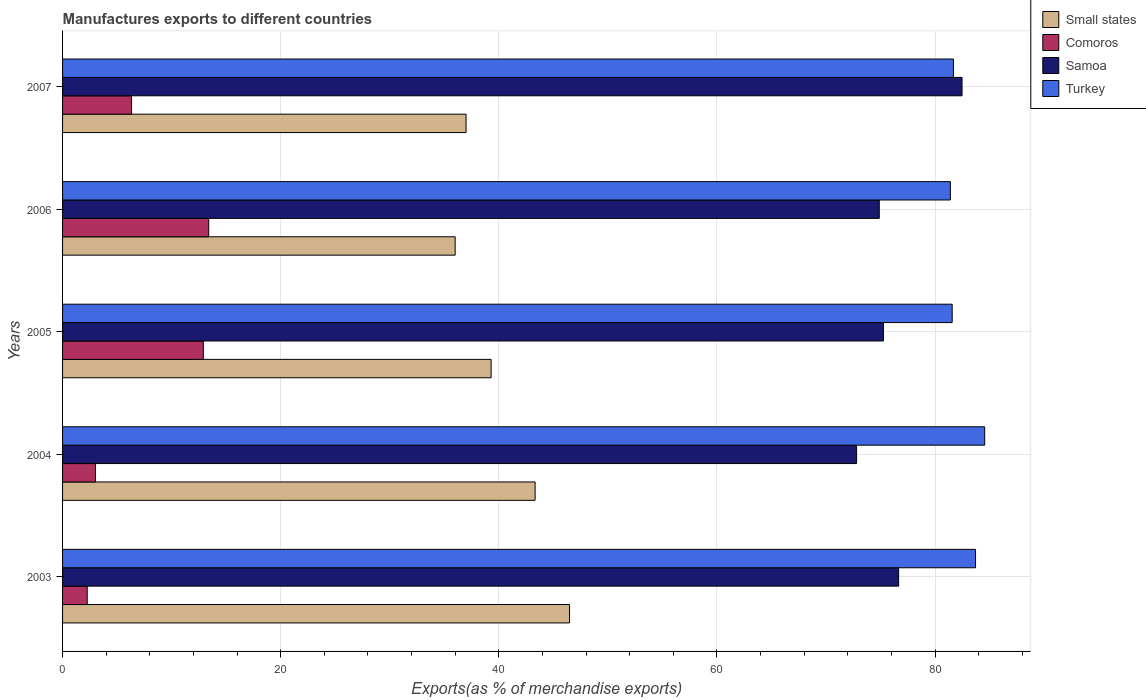What is the label of the 4th group of bars from the top?
Keep it short and to the point. 2004. In how many cases, is the number of bars for a given year not equal to the number of legend labels?
Offer a terse response. 0. What is the percentage of exports to different countries in Samoa in 2003?
Offer a terse response. 76.66. Across all years, what is the maximum percentage of exports to different countries in Small states?
Your answer should be compact. 46.48. Across all years, what is the minimum percentage of exports to different countries in Samoa?
Offer a terse response. 72.81. What is the total percentage of exports to different countries in Comoros in the graph?
Offer a very short reply. 37.9. What is the difference between the percentage of exports to different countries in Comoros in 2004 and that in 2005?
Your response must be concise. -9.89. What is the difference between the percentage of exports to different countries in Comoros in 2007 and the percentage of exports to different countries in Small states in 2003?
Provide a short and direct response. -40.16. What is the average percentage of exports to different countries in Samoa per year?
Offer a very short reply. 76.42. In the year 2003, what is the difference between the percentage of exports to different countries in Turkey and percentage of exports to different countries in Comoros?
Your response must be concise. 81.45. What is the ratio of the percentage of exports to different countries in Small states in 2003 to that in 2006?
Give a very brief answer. 1.29. Is the percentage of exports to different countries in Small states in 2005 less than that in 2007?
Your response must be concise. No. Is the difference between the percentage of exports to different countries in Turkey in 2003 and 2004 greater than the difference between the percentage of exports to different countries in Comoros in 2003 and 2004?
Provide a succinct answer. No. What is the difference between the highest and the second highest percentage of exports to different countries in Comoros?
Offer a terse response. 0.5. What is the difference between the highest and the lowest percentage of exports to different countries in Turkey?
Offer a very short reply. 3.15. Is the sum of the percentage of exports to different countries in Turkey in 2003 and 2007 greater than the maximum percentage of exports to different countries in Samoa across all years?
Provide a succinct answer. Yes. What does the 1st bar from the bottom in 2004 represents?
Your answer should be very brief. Small states. Are all the bars in the graph horizontal?
Make the answer very short. Yes. Are the values on the major ticks of X-axis written in scientific E-notation?
Offer a very short reply. No. Where does the legend appear in the graph?
Provide a short and direct response. Top right. How many legend labels are there?
Offer a very short reply. 4. How are the legend labels stacked?
Offer a very short reply. Vertical. What is the title of the graph?
Ensure brevity in your answer.  Manufactures exports to different countries. What is the label or title of the X-axis?
Offer a very short reply. Exports(as % of merchandise exports). What is the Exports(as % of merchandise exports) in Small states in 2003?
Give a very brief answer. 46.48. What is the Exports(as % of merchandise exports) in Comoros in 2003?
Your answer should be very brief. 2.26. What is the Exports(as % of merchandise exports) in Samoa in 2003?
Provide a short and direct response. 76.66. What is the Exports(as % of merchandise exports) in Turkey in 2003?
Provide a succinct answer. 83.71. What is the Exports(as % of merchandise exports) of Small states in 2004?
Provide a succinct answer. 43.33. What is the Exports(as % of merchandise exports) of Comoros in 2004?
Offer a terse response. 3.01. What is the Exports(as % of merchandise exports) of Samoa in 2004?
Your answer should be very brief. 72.81. What is the Exports(as % of merchandise exports) in Turkey in 2004?
Provide a short and direct response. 84.55. What is the Exports(as % of merchandise exports) in Small states in 2005?
Keep it short and to the point. 39.29. What is the Exports(as % of merchandise exports) in Comoros in 2005?
Provide a short and direct response. 12.9. What is the Exports(as % of merchandise exports) of Samoa in 2005?
Your response must be concise. 75.27. What is the Exports(as % of merchandise exports) in Turkey in 2005?
Provide a short and direct response. 81.57. What is the Exports(as % of merchandise exports) in Small states in 2006?
Make the answer very short. 36. What is the Exports(as % of merchandise exports) in Comoros in 2006?
Give a very brief answer. 13.4. What is the Exports(as % of merchandise exports) in Samoa in 2006?
Give a very brief answer. 74.89. What is the Exports(as % of merchandise exports) in Turkey in 2006?
Offer a terse response. 81.4. What is the Exports(as % of merchandise exports) in Small states in 2007?
Offer a terse response. 37. What is the Exports(as % of merchandise exports) of Comoros in 2007?
Keep it short and to the point. 6.33. What is the Exports(as % of merchandise exports) of Samoa in 2007?
Offer a very short reply. 82.47. What is the Exports(as % of merchandise exports) in Turkey in 2007?
Your answer should be very brief. 81.69. Across all years, what is the maximum Exports(as % of merchandise exports) in Small states?
Give a very brief answer. 46.48. Across all years, what is the maximum Exports(as % of merchandise exports) in Comoros?
Your answer should be very brief. 13.4. Across all years, what is the maximum Exports(as % of merchandise exports) in Samoa?
Give a very brief answer. 82.47. Across all years, what is the maximum Exports(as % of merchandise exports) in Turkey?
Your response must be concise. 84.55. Across all years, what is the minimum Exports(as % of merchandise exports) in Small states?
Your answer should be very brief. 36. Across all years, what is the minimum Exports(as % of merchandise exports) of Comoros?
Your answer should be very brief. 2.26. Across all years, what is the minimum Exports(as % of merchandise exports) in Samoa?
Offer a terse response. 72.81. Across all years, what is the minimum Exports(as % of merchandise exports) of Turkey?
Your answer should be very brief. 81.4. What is the total Exports(as % of merchandise exports) in Small states in the graph?
Ensure brevity in your answer.  202.1. What is the total Exports(as % of merchandise exports) in Comoros in the graph?
Keep it short and to the point. 37.9. What is the total Exports(as % of merchandise exports) in Samoa in the graph?
Offer a very short reply. 382.1. What is the total Exports(as % of merchandise exports) of Turkey in the graph?
Offer a terse response. 412.93. What is the difference between the Exports(as % of merchandise exports) of Small states in 2003 and that in 2004?
Ensure brevity in your answer.  3.16. What is the difference between the Exports(as % of merchandise exports) in Comoros in 2003 and that in 2004?
Keep it short and to the point. -0.76. What is the difference between the Exports(as % of merchandise exports) of Samoa in 2003 and that in 2004?
Your answer should be compact. 3.85. What is the difference between the Exports(as % of merchandise exports) in Turkey in 2003 and that in 2004?
Provide a succinct answer. -0.84. What is the difference between the Exports(as % of merchandise exports) in Small states in 2003 and that in 2005?
Ensure brevity in your answer.  7.19. What is the difference between the Exports(as % of merchandise exports) of Comoros in 2003 and that in 2005?
Your answer should be very brief. -10.64. What is the difference between the Exports(as % of merchandise exports) of Samoa in 2003 and that in 2005?
Ensure brevity in your answer.  1.4. What is the difference between the Exports(as % of merchandise exports) in Turkey in 2003 and that in 2005?
Provide a short and direct response. 2.14. What is the difference between the Exports(as % of merchandise exports) of Small states in 2003 and that in 2006?
Give a very brief answer. 10.49. What is the difference between the Exports(as % of merchandise exports) in Comoros in 2003 and that in 2006?
Give a very brief answer. -11.14. What is the difference between the Exports(as % of merchandise exports) of Samoa in 2003 and that in 2006?
Give a very brief answer. 1.78. What is the difference between the Exports(as % of merchandise exports) in Turkey in 2003 and that in 2006?
Keep it short and to the point. 2.31. What is the difference between the Exports(as % of merchandise exports) of Small states in 2003 and that in 2007?
Ensure brevity in your answer.  9.49. What is the difference between the Exports(as % of merchandise exports) of Comoros in 2003 and that in 2007?
Give a very brief answer. -4.07. What is the difference between the Exports(as % of merchandise exports) of Samoa in 2003 and that in 2007?
Offer a terse response. -5.81. What is the difference between the Exports(as % of merchandise exports) in Turkey in 2003 and that in 2007?
Your response must be concise. 2.03. What is the difference between the Exports(as % of merchandise exports) in Small states in 2004 and that in 2005?
Provide a succinct answer. 4.04. What is the difference between the Exports(as % of merchandise exports) in Comoros in 2004 and that in 2005?
Your response must be concise. -9.89. What is the difference between the Exports(as % of merchandise exports) of Samoa in 2004 and that in 2005?
Your answer should be very brief. -2.46. What is the difference between the Exports(as % of merchandise exports) in Turkey in 2004 and that in 2005?
Your answer should be compact. 2.98. What is the difference between the Exports(as % of merchandise exports) in Small states in 2004 and that in 2006?
Your response must be concise. 7.33. What is the difference between the Exports(as % of merchandise exports) of Comoros in 2004 and that in 2006?
Your answer should be very brief. -10.39. What is the difference between the Exports(as % of merchandise exports) in Samoa in 2004 and that in 2006?
Offer a terse response. -2.08. What is the difference between the Exports(as % of merchandise exports) of Turkey in 2004 and that in 2006?
Your answer should be compact. 3.15. What is the difference between the Exports(as % of merchandise exports) in Small states in 2004 and that in 2007?
Ensure brevity in your answer.  6.33. What is the difference between the Exports(as % of merchandise exports) in Comoros in 2004 and that in 2007?
Your answer should be compact. -3.31. What is the difference between the Exports(as % of merchandise exports) of Samoa in 2004 and that in 2007?
Offer a very short reply. -9.67. What is the difference between the Exports(as % of merchandise exports) of Turkey in 2004 and that in 2007?
Provide a succinct answer. 2.86. What is the difference between the Exports(as % of merchandise exports) of Small states in 2005 and that in 2006?
Ensure brevity in your answer.  3.3. What is the difference between the Exports(as % of merchandise exports) in Comoros in 2005 and that in 2006?
Give a very brief answer. -0.5. What is the difference between the Exports(as % of merchandise exports) in Samoa in 2005 and that in 2006?
Offer a terse response. 0.38. What is the difference between the Exports(as % of merchandise exports) in Turkey in 2005 and that in 2006?
Your answer should be compact. 0.17. What is the difference between the Exports(as % of merchandise exports) of Small states in 2005 and that in 2007?
Your response must be concise. 2.3. What is the difference between the Exports(as % of merchandise exports) of Comoros in 2005 and that in 2007?
Offer a very short reply. 6.58. What is the difference between the Exports(as % of merchandise exports) of Samoa in 2005 and that in 2007?
Your answer should be very brief. -7.21. What is the difference between the Exports(as % of merchandise exports) in Turkey in 2005 and that in 2007?
Keep it short and to the point. -0.11. What is the difference between the Exports(as % of merchandise exports) in Small states in 2006 and that in 2007?
Ensure brevity in your answer.  -1. What is the difference between the Exports(as % of merchandise exports) in Comoros in 2006 and that in 2007?
Ensure brevity in your answer.  7.07. What is the difference between the Exports(as % of merchandise exports) of Samoa in 2006 and that in 2007?
Ensure brevity in your answer.  -7.59. What is the difference between the Exports(as % of merchandise exports) of Turkey in 2006 and that in 2007?
Provide a short and direct response. -0.28. What is the difference between the Exports(as % of merchandise exports) of Small states in 2003 and the Exports(as % of merchandise exports) of Comoros in 2004?
Your response must be concise. 43.47. What is the difference between the Exports(as % of merchandise exports) of Small states in 2003 and the Exports(as % of merchandise exports) of Samoa in 2004?
Offer a terse response. -26.32. What is the difference between the Exports(as % of merchandise exports) of Small states in 2003 and the Exports(as % of merchandise exports) of Turkey in 2004?
Give a very brief answer. -38.07. What is the difference between the Exports(as % of merchandise exports) of Comoros in 2003 and the Exports(as % of merchandise exports) of Samoa in 2004?
Offer a terse response. -70.55. What is the difference between the Exports(as % of merchandise exports) in Comoros in 2003 and the Exports(as % of merchandise exports) in Turkey in 2004?
Your answer should be very brief. -82.29. What is the difference between the Exports(as % of merchandise exports) of Samoa in 2003 and the Exports(as % of merchandise exports) of Turkey in 2004?
Your answer should be compact. -7.89. What is the difference between the Exports(as % of merchandise exports) of Small states in 2003 and the Exports(as % of merchandise exports) of Comoros in 2005?
Your response must be concise. 33.58. What is the difference between the Exports(as % of merchandise exports) in Small states in 2003 and the Exports(as % of merchandise exports) in Samoa in 2005?
Your answer should be compact. -28.78. What is the difference between the Exports(as % of merchandise exports) in Small states in 2003 and the Exports(as % of merchandise exports) in Turkey in 2005?
Your response must be concise. -35.09. What is the difference between the Exports(as % of merchandise exports) of Comoros in 2003 and the Exports(as % of merchandise exports) of Samoa in 2005?
Your response must be concise. -73.01. What is the difference between the Exports(as % of merchandise exports) of Comoros in 2003 and the Exports(as % of merchandise exports) of Turkey in 2005?
Offer a terse response. -79.31. What is the difference between the Exports(as % of merchandise exports) of Samoa in 2003 and the Exports(as % of merchandise exports) of Turkey in 2005?
Your response must be concise. -4.91. What is the difference between the Exports(as % of merchandise exports) of Small states in 2003 and the Exports(as % of merchandise exports) of Comoros in 2006?
Provide a succinct answer. 33.08. What is the difference between the Exports(as % of merchandise exports) of Small states in 2003 and the Exports(as % of merchandise exports) of Samoa in 2006?
Your answer should be very brief. -28.4. What is the difference between the Exports(as % of merchandise exports) in Small states in 2003 and the Exports(as % of merchandise exports) in Turkey in 2006?
Offer a terse response. -34.92. What is the difference between the Exports(as % of merchandise exports) of Comoros in 2003 and the Exports(as % of merchandise exports) of Samoa in 2006?
Provide a succinct answer. -72.63. What is the difference between the Exports(as % of merchandise exports) of Comoros in 2003 and the Exports(as % of merchandise exports) of Turkey in 2006?
Your answer should be very brief. -79.15. What is the difference between the Exports(as % of merchandise exports) of Samoa in 2003 and the Exports(as % of merchandise exports) of Turkey in 2006?
Your answer should be compact. -4.74. What is the difference between the Exports(as % of merchandise exports) of Small states in 2003 and the Exports(as % of merchandise exports) of Comoros in 2007?
Your response must be concise. 40.16. What is the difference between the Exports(as % of merchandise exports) in Small states in 2003 and the Exports(as % of merchandise exports) in Samoa in 2007?
Offer a terse response. -35.99. What is the difference between the Exports(as % of merchandise exports) of Small states in 2003 and the Exports(as % of merchandise exports) of Turkey in 2007?
Offer a terse response. -35.2. What is the difference between the Exports(as % of merchandise exports) in Comoros in 2003 and the Exports(as % of merchandise exports) in Samoa in 2007?
Give a very brief answer. -80.22. What is the difference between the Exports(as % of merchandise exports) in Comoros in 2003 and the Exports(as % of merchandise exports) in Turkey in 2007?
Ensure brevity in your answer.  -79.43. What is the difference between the Exports(as % of merchandise exports) in Samoa in 2003 and the Exports(as % of merchandise exports) in Turkey in 2007?
Make the answer very short. -5.02. What is the difference between the Exports(as % of merchandise exports) in Small states in 2004 and the Exports(as % of merchandise exports) in Comoros in 2005?
Offer a very short reply. 30.43. What is the difference between the Exports(as % of merchandise exports) in Small states in 2004 and the Exports(as % of merchandise exports) in Samoa in 2005?
Provide a succinct answer. -31.94. What is the difference between the Exports(as % of merchandise exports) of Small states in 2004 and the Exports(as % of merchandise exports) of Turkey in 2005?
Provide a succinct answer. -38.24. What is the difference between the Exports(as % of merchandise exports) of Comoros in 2004 and the Exports(as % of merchandise exports) of Samoa in 2005?
Give a very brief answer. -72.25. What is the difference between the Exports(as % of merchandise exports) of Comoros in 2004 and the Exports(as % of merchandise exports) of Turkey in 2005?
Your answer should be very brief. -78.56. What is the difference between the Exports(as % of merchandise exports) in Samoa in 2004 and the Exports(as % of merchandise exports) in Turkey in 2005?
Give a very brief answer. -8.76. What is the difference between the Exports(as % of merchandise exports) in Small states in 2004 and the Exports(as % of merchandise exports) in Comoros in 2006?
Offer a terse response. 29.93. What is the difference between the Exports(as % of merchandise exports) in Small states in 2004 and the Exports(as % of merchandise exports) in Samoa in 2006?
Provide a succinct answer. -31.56. What is the difference between the Exports(as % of merchandise exports) of Small states in 2004 and the Exports(as % of merchandise exports) of Turkey in 2006?
Make the answer very short. -38.08. What is the difference between the Exports(as % of merchandise exports) of Comoros in 2004 and the Exports(as % of merchandise exports) of Samoa in 2006?
Make the answer very short. -71.87. What is the difference between the Exports(as % of merchandise exports) in Comoros in 2004 and the Exports(as % of merchandise exports) in Turkey in 2006?
Your answer should be very brief. -78.39. What is the difference between the Exports(as % of merchandise exports) in Samoa in 2004 and the Exports(as % of merchandise exports) in Turkey in 2006?
Provide a succinct answer. -8.6. What is the difference between the Exports(as % of merchandise exports) in Small states in 2004 and the Exports(as % of merchandise exports) in Comoros in 2007?
Make the answer very short. 37. What is the difference between the Exports(as % of merchandise exports) in Small states in 2004 and the Exports(as % of merchandise exports) in Samoa in 2007?
Offer a very short reply. -39.15. What is the difference between the Exports(as % of merchandise exports) in Small states in 2004 and the Exports(as % of merchandise exports) in Turkey in 2007?
Provide a short and direct response. -38.36. What is the difference between the Exports(as % of merchandise exports) in Comoros in 2004 and the Exports(as % of merchandise exports) in Samoa in 2007?
Offer a terse response. -79.46. What is the difference between the Exports(as % of merchandise exports) in Comoros in 2004 and the Exports(as % of merchandise exports) in Turkey in 2007?
Offer a very short reply. -78.67. What is the difference between the Exports(as % of merchandise exports) in Samoa in 2004 and the Exports(as % of merchandise exports) in Turkey in 2007?
Your answer should be very brief. -8.88. What is the difference between the Exports(as % of merchandise exports) of Small states in 2005 and the Exports(as % of merchandise exports) of Comoros in 2006?
Your response must be concise. 25.89. What is the difference between the Exports(as % of merchandise exports) in Small states in 2005 and the Exports(as % of merchandise exports) in Samoa in 2006?
Provide a succinct answer. -35.59. What is the difference between the Exports(as % of merchandise exports) of Small states in 2005 and the Exports(as % of merchandise exports) of Turkey in 2006?
Give a very brief answer. -42.11. What is the difference between the Exports(as % of merchandise exports) in Comoros in 2005 and the Exports(as % of merchandise exports) in Samoa in 2006?
Offer a very short reply. -61.98. What is the difference between the Exports(as % of merchandise exports) in Comoros in 2005 and the Exports(as % of merchandise exports) in Turkey in 2006?
Your answer should be very brief. -68.5. What is the difference between the Exports(as % of merchandise exports) in Samoa in 2005 and the Exports(as % of merchandise exports) in Turkey in 2006?
Your response must be concise. -6.14. What is the difference between the Exports(as % of merchandise exports) of Small states in 2005 and the Exports(as % of merchandise exports) of Comoros in 2007?
Make the answer very short. 32.97. What is the difference between the Exports(as % of merchandise exports) of Small states in 2005 and the Exports(as % of merchandise exports) of Samoa in 2007?
Make the answer very short. -43.18. What is the difference between the Exports(as % of merchandise exports) of Small states in 2005 and the Exports(as % of merchandise exports) of Turkey in 2007?
Give a very brief answer. -42.39. What is the difference between the Exports(as % of merchandise exports) of Comoros in 2005 and the Exports(as % of merchandise exports) of Samoa in 2007?
Your response must be concise. -69.57. What is the difference between the Exports(as % of merchandise exports) in Comoros in 2005 and the Exports(as % of merchandise exports) in Turkey in 2007?
Your answer should be compact. -68.78. What is the difference between the Exports(as % of merchandise exports) in Samoa in 2005 and the Exports(as % of merchandise exports) in Turkey in 2007?
Give a very brief answer. -6.42. What is the difference between the Exports(as % of merchandise exports) of Small states in 2006 and the Exports(as % of merchandise exports) of Comoros in 2007?
Provide a succinct answer. 29.67. What is the difference between the Exports(as % of merchandise exports) in Small states in 2006 and the Exports(as % of merchandise exports) in Samoa in 2007?
Offer a terse response. -46.48. What is the difference between the Exports(as % of merchandise exports) of Small states in 2006 and the Exports(as % of merchandise exports) of Turkey in 2007?
Give a very brief answer. -45.69. What is the difference between the Exports(as % of merchandise exports) of Comoros in 2006 and the Exports(as % of merchandise exports) of Samoa in 2007?
Your response must be concise. -69.08. What is the difference between the Exports(as % of merchandise exports) of Comoros in 2006 and the Exports(as % of merchandise exports) of Turkey in 2007?
Your answer should be very brief. -68.29. What is the difference between the Exports(as % of merchandise exports) of Samoa in 2006 and the Exports(as % of merchandise exports) of Turkey in 2007?
Your answer should be compact. -6.8. What is the average Exports(as % of merchandise exports) of Small states per year?
Ensure brevity in your answer.  40.42. What is the average Exports(as % of merchandise exports) of Comoros per year?
Provide a succinct answer. 7.58. What is the average Exports(as % of merchandise exports) in Samoa per year?
Provide a succinct answer. 76.42. What is the average Exports(as % of merchandise exports) in Turkey per year?
Provide a short and direct response. 82.59. In the year 2003, what is the difference between the Exports(as % of merchandise exports) in Small states and Exports(as % of merchandise exports) in Comoros?
Offer a very short reply. 44.23. In the year 2003, what is the difference between the Exports(as % of merchandise exports) in Small states and Exports(as % of merchandise exports) in Samoa?
Ensure brevity in your answer.  -30.18. In the year 2003, what is the difference between the Exports(as % of merchandise exports) in Small states and Exports(as % of merchandise exports) in Turkey?
Your answer should be compact. -37.23. In the year 2003, what is the difference between the Exports(as % of merchandise exports) in Comoros and Exports(as % of merchandise exports) in Samoa?
Your answer should be very brief. -74.4. In the year 2003, what is the difference between the Exports(as % of merchandise exports) in Comoros and Exports(as % of merchandise exports) in Turkey?
Offer a very short reply. -81.45. In the year 2003, what is the difference between the Exports(as % of merchandise exports) of Samoa and Exports(as % of merchandise exports) of Turkey?
Your answer should be very brief. -7.05. In the year 2004, what is the difference between the Exports(as % of merchandise exports) in Small states and Exports(as % of merchandise exports) in Comoros?
Give a very brief answer. 40.32. In the year 2004, what is the difference between the Exports(as % of merchandise exports) of Small states and Exports(as % of merchandise exports) of Samoa?
Your answer should be very brief. -29.48. In the year 2004, what is the difference between the Exports(as % of merchandise exports) in Small states and Exports(as % of merchandise exports) in Turkey?
Offer a terse response. -41.22. In the year 2004, what is the difference between the Exports(as % of merchandise exports) of Comoros and Exports(as % of merchandise exports) of Samoa?
Your response must be concise. -69.79. In the year 2004, what is the difference between the Exports(as % of merchandise exports) of Comoros and Exports(as % of merchandise exports) of Turkey?
Offer a very short reply. -81.54. In the year 2004, what is the difference between the Exports(as % of merchandise exports) in Samoa and Exports(as % of merchandise exports) in Turkey?
Your answer should be compact. -11.74. In the year 2005, what is the difference between the Exports(as % of merchandise exports) in Small states and Exports(as % of merchandise exports) in Comoros?
Provide a succinct answer. 26.39. In the year 2005, what is the difference between the Exports(as % of merchandise exports) of Small states and Exports(as % of merchandise exports) of Samoa?
Your answer should be compact. -35.97. In the year 2005, what is the difference between the Exports(as % of merchandise exports) of Small states and Exports(as % of merchandise exports) of Turkey?
Ensure brevity in your answer.  -42.28. In the year 2005, what is the difference between the Exports(as % of merchandise exports) of Comoros and Exports(as % of merchandise exports) of Samoa?
Ensure brevity in your answer.  -62.36. In the year 2005, what is the difference between the Exports(as % of merchandise exports) in Comoros and Exports(as % of merchandise exports) in Turkey?
Ensure brevity in your answer.  -68.67. In the year 2005, what is the difference between the Exports(as % of merchandise exports) of Samoa and Exports(as % of merchandise exports) of Turkey?
Offer a very short reply. -6.31. In the year 2006, what is the difference between the Exports(as % of merchandise exports) of Small states and Exports(as % of merchandise exports) of Comoros?
Provide a short and direct response. 22.6. In the year 2006, what is the difference between the Exports(as % of merchandise exports) of Small states and Exports(as % of merchandise exports) of Samoa?
Keep it short and to the point. -38.89. In the year 2006, what is the difference between the Exports(as % of merchandise exports) in Small states and Exports(as % of merchandise exports) in Turkey?
Ensure brevity in your answer.  -45.41. In the year 2006, what is the difference between the Exports(as % of merchandise exports) in Comoros and Exports(as % of merchandise exports) in Samoa?
Your response must be concise. -61.49. In the year 2006, what is the difference between the Exports(as % of merchandise exports) in Comoros and Exports(as % of merchandise exports) in Turkey?
Make the answer very short. -68. In the year 2006, what is the difference between the Exports(as % of merchandise exports) of Samoa and Exports(as % of merchandise exports) of Turkey?
Keep it short and to the point. -6.52. In the year 2007, what is the difference between the Exports(as % of merchandise exports) in Small states and Exports(as % of merchandise exports) in Comoros?
Your answer should be very brief. 30.67. In the year 2007, what is the difference between the Exports(as % of merchandise exports) in Small states and Exports(as % of merchandise exports) in Samoa?
Ensure brevity in your answer.  -45.48. In the year 2007, what is the difference between the Exports(as % of merchandise exports) of Small states and Exports(as % of merchandise exports) of Turkey?
Make the answer very short. -44.69. In the year 2007, what is the difference between the Exports(as % of merchandise exports) in Comoros and Exports(as % of merchandise exports) in Samoa?
Your answer should be compact. -76.15. In the year 2007, what is the difference between the Exports(as % of merchandise exports) in Comoros and Exports(as % of merchandise exports) in Turkey?
Offer a very short reply. -75.36. In the year 2007, what is the difference between the Exports(as % of merchandise exports) in Samoa and Exports(as % of merchandise exports) in Turkey?
Your answer should be compact. 0.79. What is the ratio of the Exports(as % of merchandise exports) of Small states in 2003 to that in 2004?
Offer a very short reply. 1.07. What is the ratio of the Exports(as % of merchandise exports) of Comoros in 2003 to that in 2004?
Make the answer very short. 0.75. What is the ratio of the Exports(as % of merchandise exports) of Samoa in 2003 to that in 2004?
Your answer should be compact. 1.05. What is the ratio of the Exports(as % of merchandise exports) in Small states in 2003 to that in 2005?
Provide a short and direct response. 1.18. What is the ratio of the Exports(as % of merchandise exports) in Comoros in 2003 to that in 2005?
Offer a very short reply. 0.17. What is the ratio of the Exports(as % of merchandise exports) in Samoa in 2003 to that in 2005?
Your answer should be very brief. 1.02. What is the ratio of the Exports(as % of merchandise exports) of Turkey in 2003 to that in 2005?
Give a very brief answer. 1.03. What is the ratio of the Exports(as % of merchandise exports) in Small states in 2003 to that in 2006?
Offer a very short reply. 1.29. What is the ratio of the Exports(as % of merchandise exports) of Comoros in 2003 to that in 2006?
Provide a short and direct response. 0.17. What is the ratio of the Exports(as % of merchandise exports) in Samoa in 2003 to that in 2006?
Your answer should be very brief. 1.02. What is the ratio of the Exports(as % of merchandise exports) of Turkey in 2003 to that in 2006?
Make the answer very short. 1.03. What is the ratio of the Exports(as % of merchandise exports) in Small states in 2003 to that in 2007?
Offer a very short reply. 1.26. What is the ratio of the Exports(as % of merchandise exports) of Comoros in 2003 to that in 2007?
Give a very brief answer. 0.36. What is the ratio of the Exports(as % of merchandise exports) in Samoa in 2003 to that in 2007?
Provide a short and direct response. 0.93. What is the ratio of the Exports(as % of merchandise exports) in Turkey in 2003 to that in 2007?
Provide a succinct answer. 1.02. What is the ratio of the Exports(as % of merchandise exports) of Small states in 2004 to that in 2005?
Ensure brevity in your answer.  1.1. What is the ratio of the Exports(as % of merchandise exports) in Comoros in 2004 to that in 2005?
Offer a very short reply. 0.23. What is the ratio of the Exports(as % of merchandise exports) in Samoa in 2004 to that in 2005?
Provide a succinct answer. 0.97. What is the ratio of the Exports(as % of merchandise exports) of Turkey in 2004 to that in 2005?
Ensure brevity in your answer.  1.04. What is the ratio of the Exports(as % of merchandise exports) in Small states in 2004 to that in 2006?
Your response must be concise. 1.2. What is the ratio of the Exports(as % of merchandise exports) of Comoros in 2004 to that in 2006?
Provide a succinct answer. 0.22. What is the ratio of the Exports(as % of merchandise exports) in Samoa in 2004 to that in 2006?
Offer a terse response. 0.97. What is the ratio of the Exports(as % of merchandise exports) of Turkey in 2004 to that in 2006?
Give a very brief answer. 1.04. What is the ratio of the Exports(as % of merchandise exports) in Small states in 2004 to that in 2007?
Provide a succinct answer. 1.17. What is the ratio of the Exports(as % of merchandise exports) of Comoros in 2004 to that in 2007?
Make the answer very short. 0.48. What is the ratio of the Exports(as % of merchandise exports) in Samoa in 2004 to that in 2007?
Provide a succinct answer. 0.88. What is the ratio of the Exports(as % of merchandise exports) in Turkey in 2004 to that in 2007?
Offer a terse response. 1.04. What is the ratio of the Exports(as % of merchandise exports) of Small states in 2005 to that in 2006?
Ensure brevity in your answer.  1.09. What is the ratio of the Exports(as % of merchandise exports) of Comoros in 2005 to that in 2006?
Make the answer very short. 0.96. What is the ratio of the Exports(as % of merchandise exports) of Turkey in 2005 to that in 2006?
Keep it short and to the point. 1. What is the ratio of the Exports(as % of merchandise exports) of Small states in 2005 to that in 2007?
Provide a short and direct response. 1.06. What is the ratio of the Exports(as % of merchandise exports) of Comoros in 2005 to that in 2007?
Offer a very short reply. 2.04. What is the ratio of the Exports(as % of merchandise exports) in Samoa in 2005 to that in 2007?
Offer a very short reply. 0.91. What is the ratio of the Exports(as % of merchandise exports) of Turkey in 2005 to that in 2007?
Keep it short and to the point. 1. What is the ratio of the Exports(as % of merchandise exports) in Comoros in 2006 to that in 2007?
Your answer should be compact. 2.12. What is the ratio of the Exports(as % of merchandise exports) of Samoa in 2006 to that in 2007?
Keep it short and to the point. 0.91. What is the ratio of the Exports(as % of merchandise exports) in Turkey in 2006 to that in 2007?
Your answer should be compact. 1. What is the difference between the highest and the second highest Exports(as % of merchandise exports) in Small states?
Keep it short and to the point. 3.16. What is the difference between the highest and the second highest Exports(as % of merchandise exports) of Comoros?
Make the answer very short. 0.5. What is the difference between the highest and the second highest Exports(as % of merchandise exports) of Samoa?
Your answer should be very brief. 5.81. What is the difference between the highest and the second highest Exports(as % of merchandise exports) in Turkey?
Offer a very short reply. 0.84. What is the difference between the highest and the lowest Exports(as % of merchandise exports) in Small states?
Your answer should be very brief. 10.49. What is the difference between the highest and the lowest Exports(as % of merchandise exports) of Comoros?
Keep it short and to the point. 11.14. What is the difference between the highest and the lowest Exports(as % of merchandise exports) of Samoa?
Your response must be concise. 9.67. What is the difference between the highest and the lowest Exports(as % of merchandise exports) in Turkey?
Make the answer very short. 3.15. 